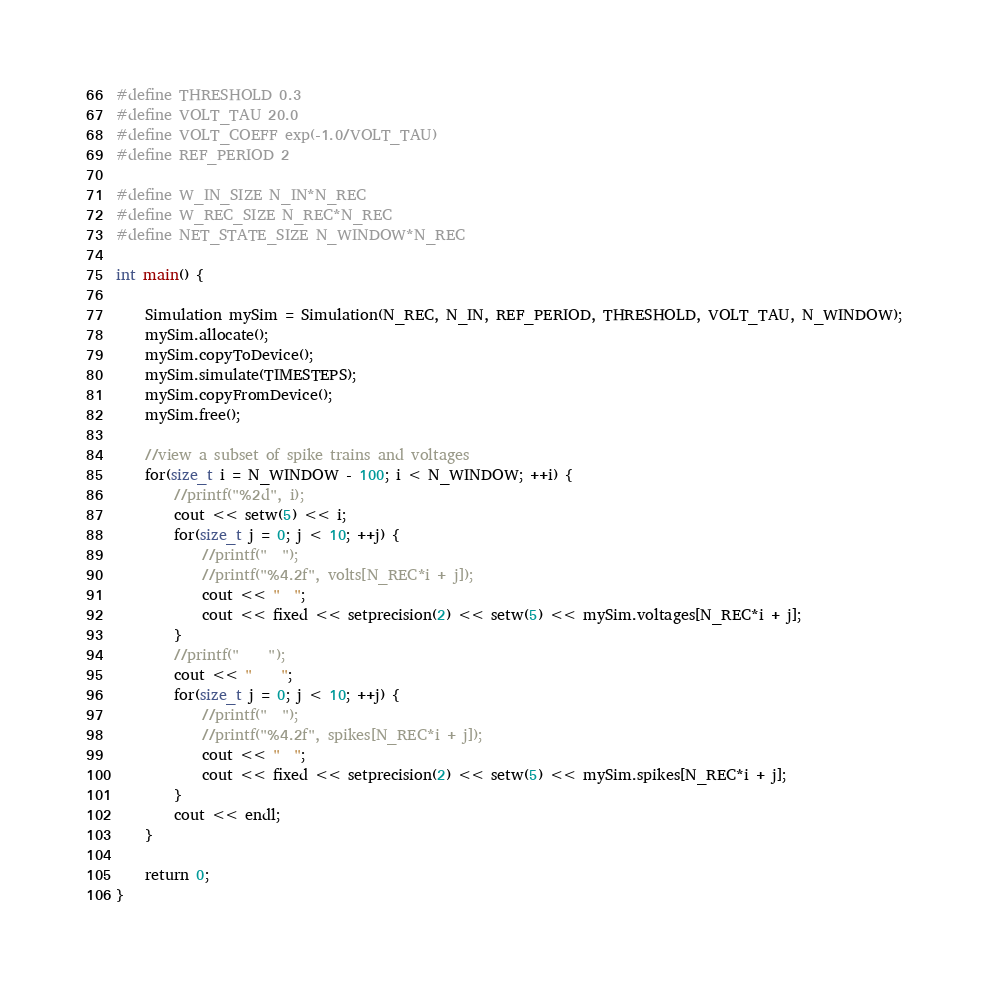Convert code to text. <code><loc_0><loc_0><loc_500><loc_500><_Cuda_>#define THRESHOLD 0.3
#define VOLT_TAU 20.0
#define VOLT_COEFF exp(-1.0/VOLT_TAU)
#define REF_PERIOD 2

#define W_IN_SIZE N_IN*N_REC
#define W_REC_SIZE N_REC*N_REC
#define NET_STATE_SIZE N_WINDOW*N_REC

int main() {

    Simulation mySim = Simulation(N_REC, N_IN, REF_PERIOD, THRESHOLD, VOLT_TAU, N_WINDOW);
    mySim.allocate();
    mySim.copyToDevice();
    mySim.simulate(TIMESTEPS);
    mySim.copyFromDevice();
    mySim.free();

    //view a subset of spike trains and voltages
    for(size_t i = N_WINDOW - 100; i < N_WINDOW; ++i) {
        //printf("%2d", i);
        cout << setw(5) << i;
        for(size_t j = 0; j < 10; ++j) {
            //printf("  ");
            //printf("%4.2f", volts[N_REC*i + j]);
            cout << "  ";
            cout << fixed << setprecision(2) << setw(5) << mySim.voltages[N_REC*i + j];
        }
        //printf("    ");
        cout << "    ";
        for(size_t j = 0; j < 10; ++j) {
            //printf("  ");
            //printf("%4.2f", spikes[N_REC*i + j]);
            cout << "  ";
            cout << fixed << setprecision(2) << setw(5) << mySim.spikes[N_REC*i + j];
        }
        cout << endl;
    }

    return 0;
}
</code> 